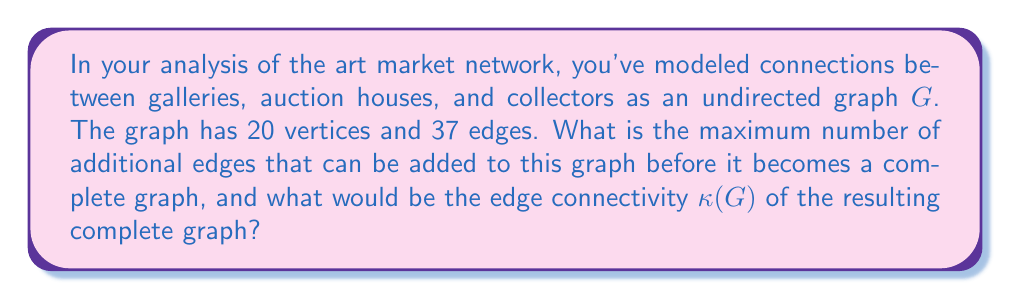Can you answer this question? To solve this problem, we need to follow these steps:

1. Calculate the number of edges in a complete graph with 20 vertices.
2. Determine how many edges need to be added to reach this number.
3. Understand the edge connectivity of a complete graph.

Step 1: Number of edges in a complete graph
In a complete graph with $n$ vertices, each vertex is connected to every other vertex. The number of edges in a complete graph is given by the formula:

$$ E = \frac{n(n-1)}{2} $$

Where $E$ is the number of edges and $n$ is the number of vertices.

For our graph with 20 vertices:

$$ E = \frac{20(20-1)}{2} = \frac{20 \times 19}{2} = 190 $$

Step 2: Additional edges needed
The current graph has 37 edges. To reach a complete graph, we need to add:

$$ 190 - 37 = 153 \text{ edges} $$

Step 3: Edge connectivity of a complete graph
The edge connectivity $\kappa(G)$ of a graph is the minimum number of edges that need to be removed to disconnect the graph. In a complete graph, every vertex is connected to every other vertex, so to disconnect any vertex, we need to remove all edges connected to it.

In a complete graph with $n$ vertices, each vertex has degree $n-1$. Therefore, the edge connectivity of a complete graph is:

$$ \kappa(G) = n - 1 $$

For our graph with 20 vertices, the edge connectivity of the resulting complete graph would be:

$$ \kappa(G) = 20 - 1 = 19 $$
Answer: 153 additional edges can be added, and the edge connectivity $\kappa(G)$ of the resulting complete graph would be 19. 